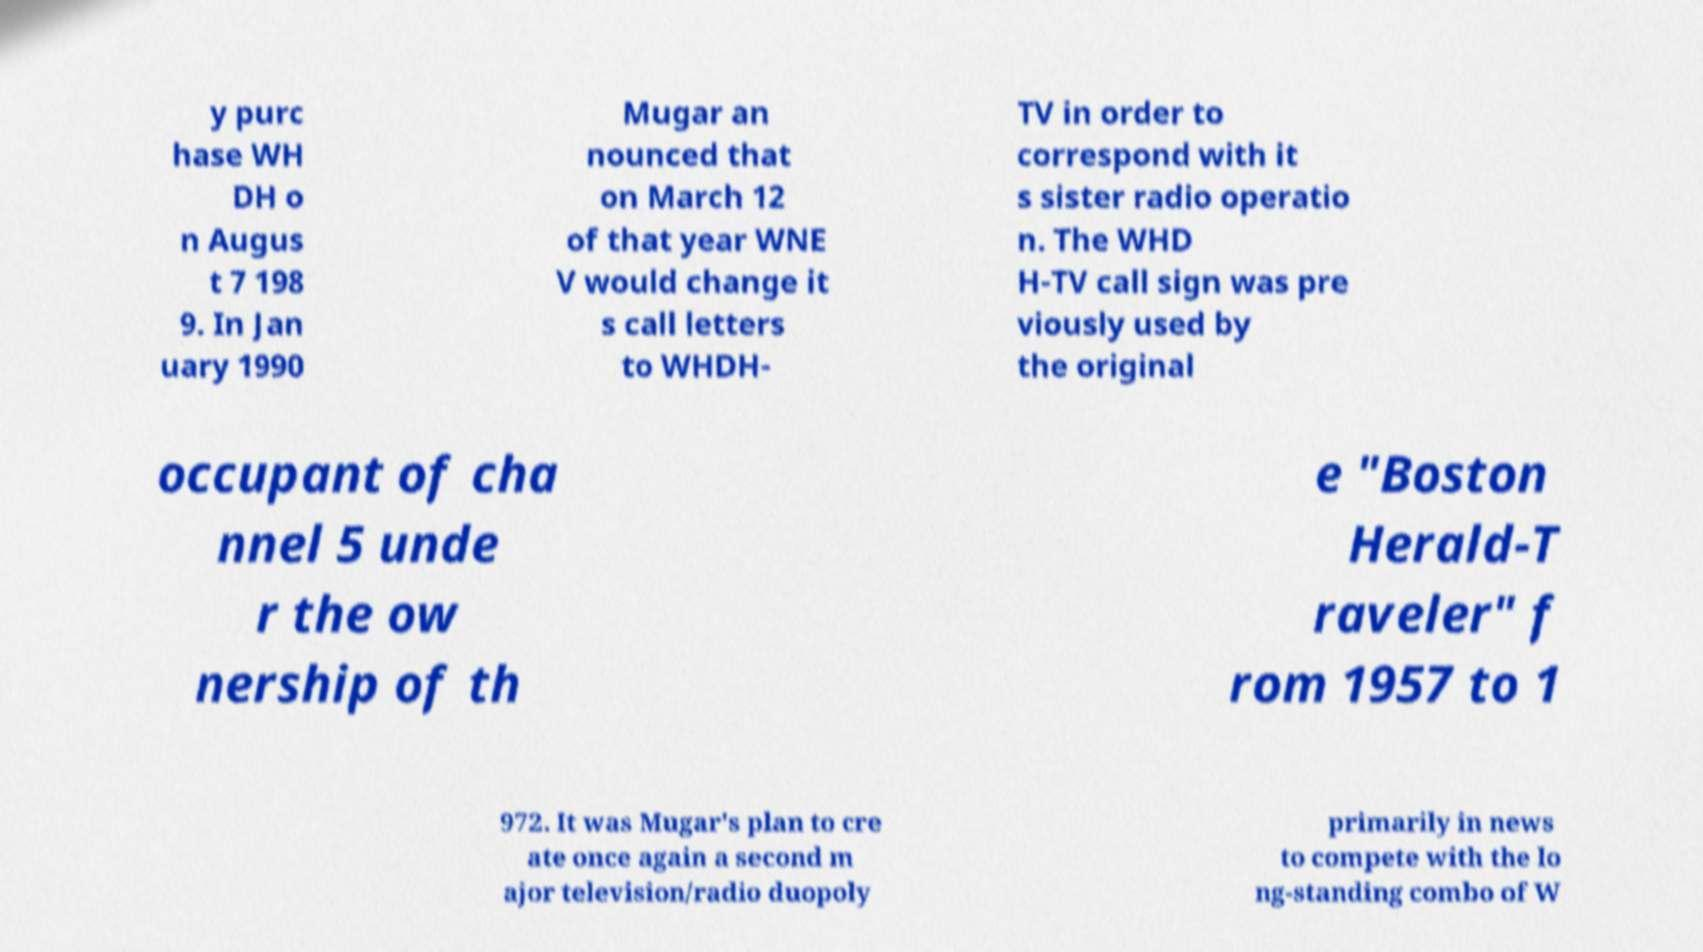Please identify and transcribe the text found in this image. y purc hase WH DH o n Augus t 7 198 9. In Jan uary 1990 Mugar an nounced that on March 12 of that year WNE V would change it s call letters to WHDH- TV in order to correspond with it s sister radio operatio n. The WHD H-TV call sign was pre viously used by the original occupant of cha nnel 5 unde r the ow nership of th e "Boston Herald-T raveler" f rom 1957 to 1 972. It was Mugar's plan to cre ate once again a second m ajor television/radio duopoly primarily in news to compete with the lo ng-standing combo of W 